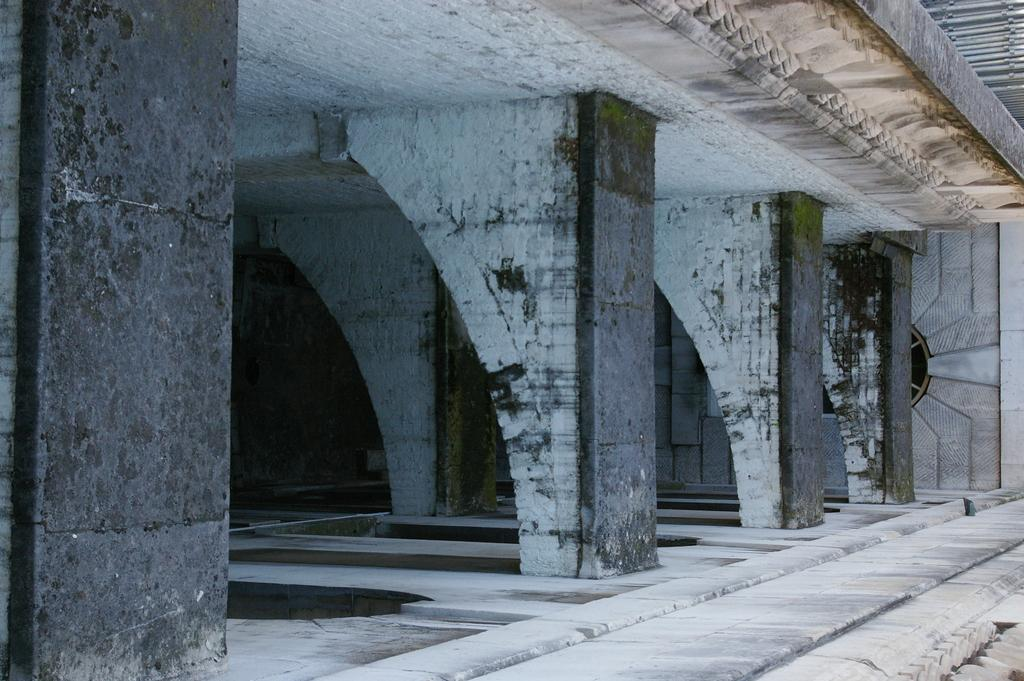What type of location is depicted in the image? The image shows an interior view of a building. What architectural features can be seen in the image? There are pillars visible in the image. How much sand can be seen on the floor in the image? There is no sand visible on the floor in the image. Who is the creator of the building depicted in the image? The creator of the building is not mentioned or visible in the image. 